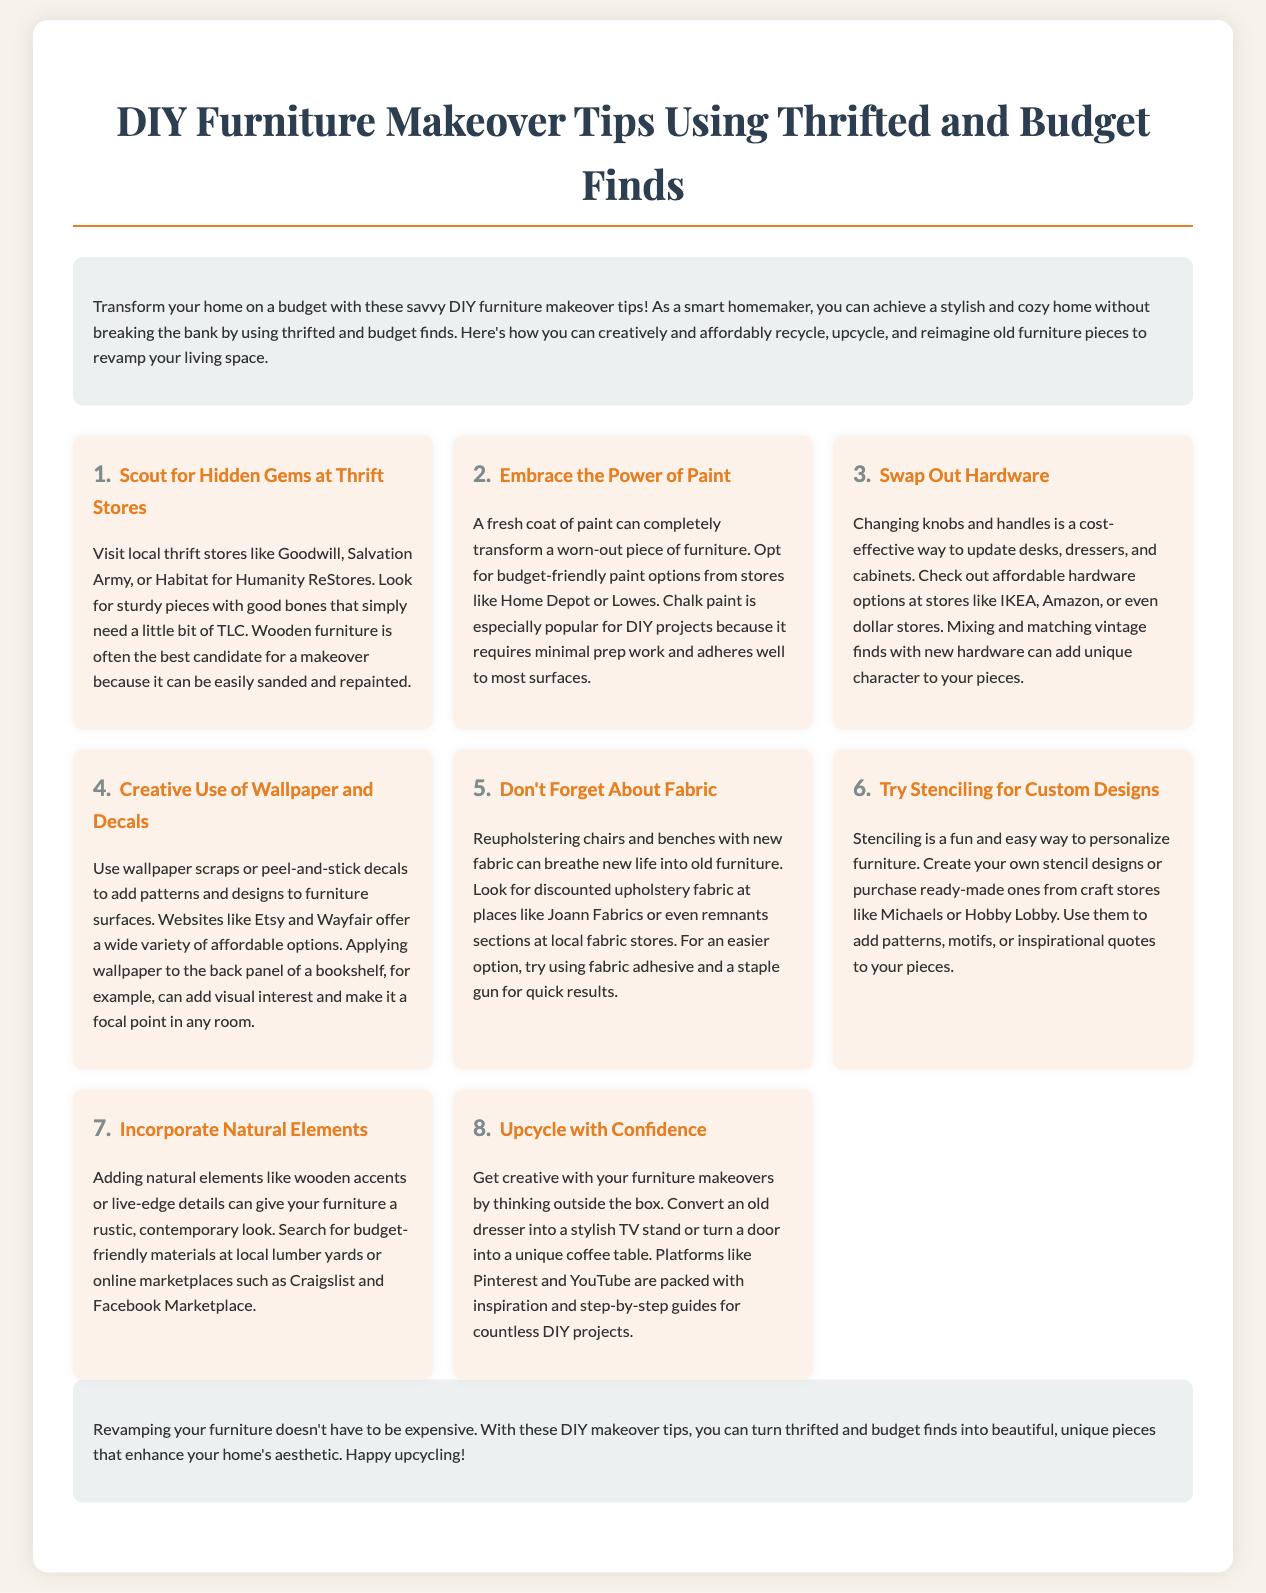what is the title of the document? The title of the document is mentioned at the top of the page.
Answer: DIY Furniture Makeover Tips Using Thrifted and Budget Finds how many tips are provided in the document? The document lists a total of eight tips for DIY furniture makeovers.
Answer: 8 which store is mentioned as a place to find upholstery fabric? The document lists Joann Fabrics as a location where discounted upholstery fabric can be found.
Answer: Joann Fabrics what is a recommended use for wallpaper scraps? The document suggests using wallpaper scraps to add patterns and designs to furniture surfaces.
Answer: Add patterns and designs which tip suggests changing knobs and handles? The document specifically mentions swapping out hardware as a cost-effective update.
Answer: Swap Out Hardware what type of paint is suggested for DIY projects? Chalk paint is highlighted as a popular choice for DIY furniture makeovers.
Answer: Chalk paint which online platform is mentioned for DIY project inspiration? The document refers to Pinterest as a source for inspiration for DIY projects.
Answer: Pinterest what is one natural element suggested to incorporate into furniture makeovers? The document suggests adding wooden accents as a natural element.
Answer: Wooden accents 